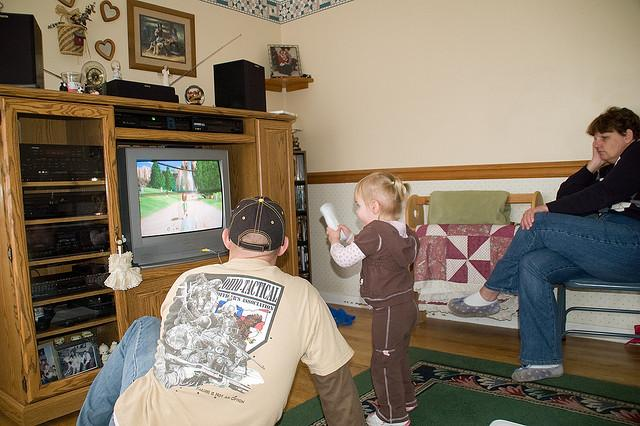What is the young girl doing with the white object?

Choices:
A) singing
B) playing game
C) exercising
D) dancing playing game 